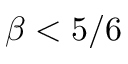<formula> <loc_0><loc_0><loc_500><loc_500>\beta < 5 / 6</formula> 